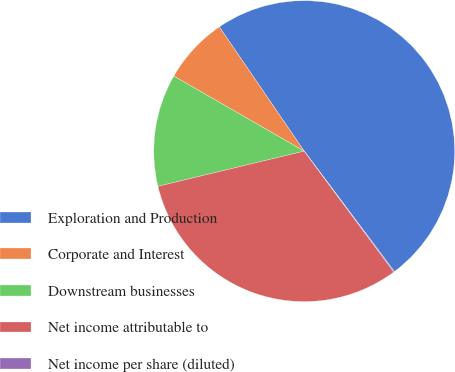Convert chart to OTSL. <chart><loc_0><loc_0><loc_500><loc_500><pie_chart><fcel>Exploration and Production<fcel>Corporate and Interest<fcel>Downstream businesses<fcel>Net income attributable to<fcel>Net income per share (diluted)<nl><fcel>49.3%<fcel>7.15%<fcel>12.07%<fcel>31.39%<fcel>0.09%<nl></chart> 